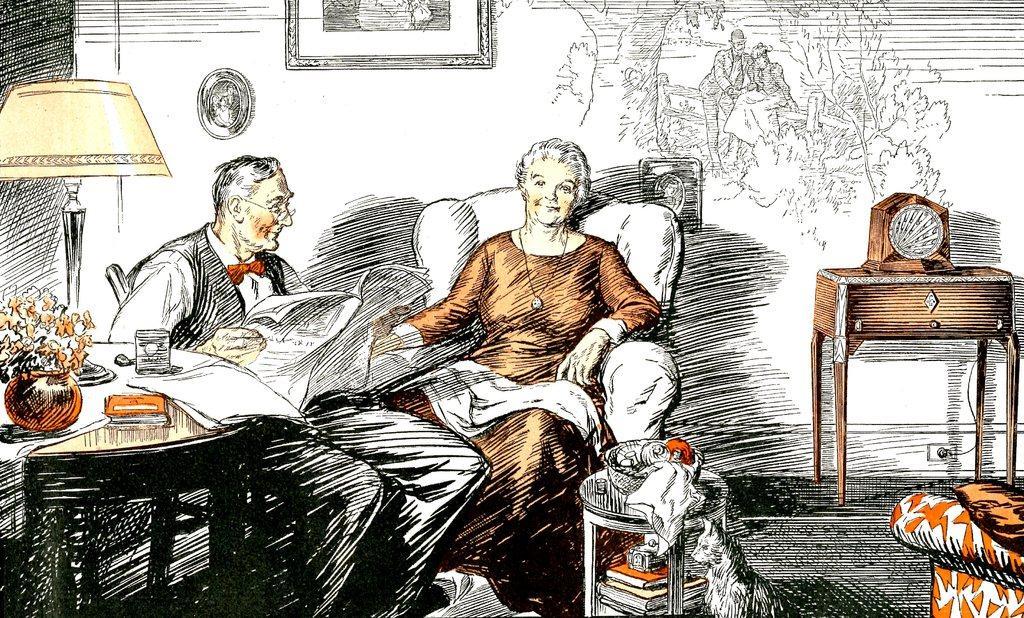Describe this image in one or two sentences. This is a sketch. In this image there is a woman sitting on the chair and there is a man sitting and holding the paper. On the left side of the image there is a lamp, flower vase and there are objects on the table. On the right side of the image there is an object on the table. In the foreground there is a bowl and there are books on the table and there is a cat. At the back there is a frame and there is an object on the wall and there is painting on the wall. At the bottom there is a floor. 